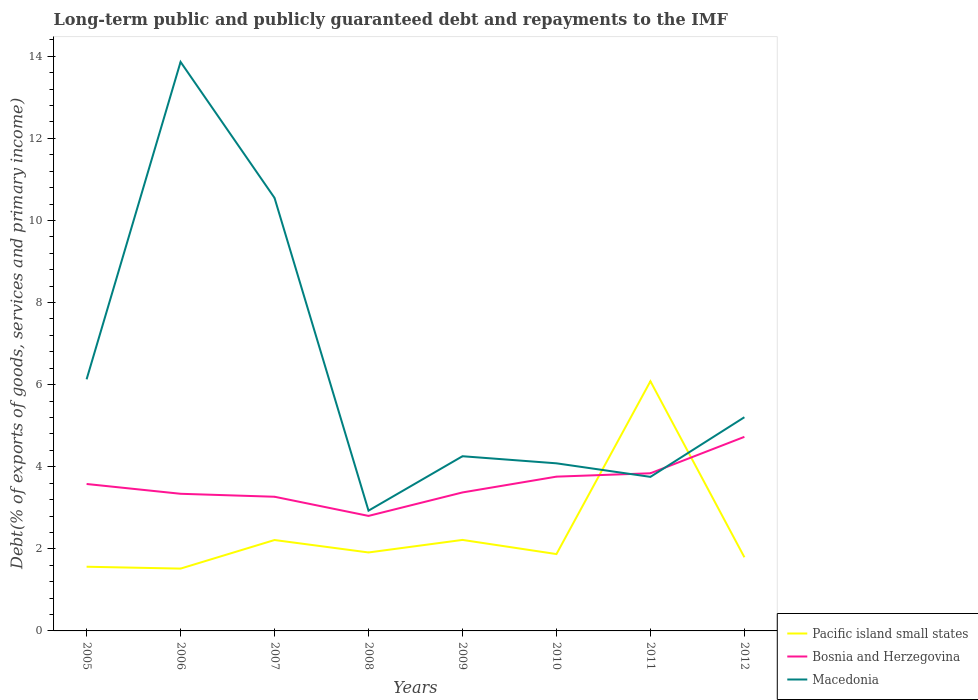Does the line corresponding to Pacific island small states intersect with the line corresponding to Macedonia?
Your answer should be compact. Yes. Is the number of lines equal to the number of legend labels?
Your response must be concise. Yes. Across all years, what is the maximum debt and repayments in Macedonia?
Offer a terse response. 2.93. In which year was the debt and repayments in Bosnia and Herzegovina maximum?
Ensure brevity in your answer.  2008. What is the total debt and repayments in Bosnia and Herzegovina in the graph?
Provide a short and direct response. -1.35. What is the difference between the highest and the second highest debt and repayments in Macedonia?
Your answer should be compact. 10.93. Is the debt and repayments in Bosnia and Herzegovina strictly greater than the debt and repayments in Pacific island small states over the years?
Ensure brevity in your answer.  No. How many lines are there?
Provide a short and direct response. 3. How many years are there in the graph?
Make the answer very short. 8. What is the difference between two consecutive major ticks on the Y-axis?
Offer a very short reply. 2. Does the graph contain any zero values?
Your response must be concise. No. How are the legend labels stacked?
Your answer should be compact. Vertical. What is the title of the graph?
Make the answer very short. Long-term public and publicly guaranteed debt and repayments to the IMF. What is the label or title of the X-axis?
Keep it short and to the point. Years. What is the label or title of the Y-axis?
Offer a very short reply. Debt(% of exports of goods, services and primary income). What is the Debt(% of exports of goods, services and primary income) of Pacific island small states in 2005?
Give a very brief answer. 1.56. What is the Debt(% of exports of goods, services and primary income) of Bosnia and Herzegovina in 2005?
Make the answer very short. 3.58. What is the Debt(% of exports of goods, services and primary income) of Macedonia in 2005?
Your answer should be compact. 6.13. What is the Debt(% of exports of goods, services and primary income) of Pacific island small states in 2006?
Ensure brevity in your answer.  1.52. What is the Debt(% of exports of goods, services and primary income) in Bosnia and Herzegovina in 2006?
Provide a succinct answer. 3.34. What is the Debt(% of exports of goods, services and primary income) in Macedonia in 2006?
Provide a succinct answer. 13.86. What is the Debt(% of exports of goods, services and primary income) of Pacific island small states in 2007?
Ensure brevity in your answer.  2.21. What is the Debt(% of exports of goods, services and primary income) in Bosnia and Herzegovina in 2007?
Make the answer very short. 3.27. What is the Debt(% of exports of goods, services and primary income) in Macedonia in 2007?
Provide a succinct answer. 10.55. What is the Debt(% of exports of goods, services and primary income) of Pacific island small states in 2008?
Give a very brief answer. 1.91. What is the Debt(% of exports of goods, services and primary income) of Bosnia and Herzegovina in 2008?
Offer a terse response. 2.8. What is the Debt(% of exports of goods, services and primary income) in Macedonia in 2008?
Your answer should be compact. 2.93. What is the Debt(% of exports of goods, services and primary income) of Pacific island small states in 2009?
Ensure brevity in your answer.  2.22. What is the Debt(% of exports of goods, services and primary income) of Bosnia and Herzegovina in 2009?
Offer a very short reply. 3.37. What is the Debt(% of exports of goods, services and primary income) of Macedonia in 2009?
Offer a terse response. 4.26. What is the Debt(% of exports of goods, services and primary income) of Pacific island small states in 2010?
Offer a very short reply. 1.87. What is the Debt(% of exports of goods, services and primary income) of Bosnia and Herzegovina in 2010?
Offer a terse response. 3.76. What is the Debt(% of exports of goods, services and primary income) in Macedonia in 2010?
Your response must be concise. 4.08. What is the Debt(% of exports of goods, services and primary income) of Pacific island small states in 2011?
Offer a very short reply. 6.08. What is the Debt(% of exports of goods, services and primary income) of Bosnia and Herzegovina in 2011?
Your response must be concise. 3.84. What is the Debt(% of exports of goods, services and primary income) of Macedonia in 2011?
Provide a short and direct response. 3.75. What is the Debt(% of exports of goods, services and primary income) in Pacific island small states in 2012?
Your answer should be compact. 1.79. What is the Debt(% of exports of goods, services and primary income) of Bosnia and Herzegovina in 2012?
Provide a succinct answer. 4.73. What is the Debt(% of exports of goods, services and primary income) in Macedonia in 2012?
Make the answer very short. 5.21. Across all years, what is the maximum Debt(% of exports of goods, services and primary income) in Pacific island small states?
Provide a short and direct response. 6.08. Across all years, what is the maximum Debt(% of exports of goods, services and primary income) in Bosnia and Herzegovina?
Give a very brief answer. 4.73. Across all years, what is the maximum Debt(% of exports of goods, services and primary income) of Macedonia?
Give a very brief answer. 13.86. Across all years, what is the minimum Debt(% of exports of goods, services and primary income) in Pacific island small states?
Your answer should be compact. 1.52. Across all years, what is the minimum Debt(% of exports of goods, services and primary income) of Bosnia and Herzegovina?
Offer a terse response. 2.8. Across all years, what is the minimum Debt(% of exports of goods, services and primary income) of Macedonia?
Ensure brevity in your answer.  2.93. What is the total Debt(% of exports of goods, services and primary income) in Pacific island small states in the graph?
Make the answer very short. 19.18. What is the total Debt(% of exports of goods, services and primary income) of Bosnia and Herzegovina in the graph?
Give a very brief answer. 28.7. What is the total Debt(% of exports of goods, services and primary income) in Macedonia in the graph?
Your answer should be very brief. 50.77. What is the difference between the Debt(% of exports of goods, services and primary income) of Pacific island small states in 2005 and that in 2006?
Provide a short and direct response. 0.05. What is the difference between the Debt(% of exports of goods, services and primary income) of Bosnia and Herzegovina in 2005 and that in 2006?
Your answer should be very brief. 0.24. What is the difference between the Debt(% of exports of goods, services and primary income) in Macedonia in 2005 and that in 2006?
Give a very brief answer. -7.73. What is the difference between the Debt(% of exports of goods, services and primary income) in Pacific island small states in 2005 and that in 2007?
Keep it short and to the point. -0.65. What is the difference between the Debt(% of exports of goods, services and primary income) in Bosnia and Herzegovina in 2005 and that in 2007?
Your answer should be compact. 0.31. What is the difference between the Debt(% of exports of goods, services and primary income) in Macedonia in 2005 and that in 2007?
Keep it short and to the point. -4.42. What is the difference between the Debt(% of exports of goods, services and primary income) in Pacific island small states in 2005 and that in 2008?
Provide a succinct answer. -0.35. What is the difference between the Debt(% of exports of goods, services and primary income) in Pacific island small states in 2005 and that in 2009?
Give a very brief answer. -0.65. What is the difference between the Debt(% of exports of goods, services and primary income) in Bosnia and Herzegovina in 2005 and that in 2009?
Keep it short and to the point. 0.21. What is the difference between the Debt(% of exports of goods, services and primary income) in Macedonia in 2005 and that in 2009?
Your response must be concise. 1.87. What is the difference between the Debt(% of exports of goods, services and primary income) in Pacific island small states in 2005 and that in 2010?
Offer a very short reply. -0.31. What is the difference between the Debt(% of exports of goods, services and primary income) in Bosnia and Herzegovina in 2005 and that in 2010?
Offer a terse response. -0.18. What is the difference between the Debt(% of exports of goods, services and primary income) in Macedonia in 2005 and that in 2010?
Ensure brevity in your answer.  2.05. What is the difference between the Debt(% of exports of goods, services and primary income) of Pacific island small states in 2005 and that in 2011?
Provide a succinct answer. -4.52. What is the difference between the Debt(% of exports of goods, services and primary income) in Bosnia and Herzegovina in 2005 and that in 2011?
Keep it short and to the point. -0.26. What is the difference between the Debt(% of exports of goods, services and primary income) of Macedonia in 2005 and that in 2011?
Provide a succinct answer. 2.38. What is the difference between the Debt(% of exports of goods, services and primary income) in Pacific island small states in 2005 and that in 2012?
Make the answer very short. -0.23. What is the difference between the Debt(% of exports of goods, services and primary income) in Bosnia and Herzegovina in 2005 and that in 2012?
Make the answer very short. -1.15. What is the difference between the Debt(% of exports of goods, services and primary income) in Macedonia in 2005 and that in 2012?
Keep it short and to the point. 0.92. What is the difference between the Debt(% of exports of goods, services and primary income) in Pacific island small states in 2006 and that in 2007?
Your answer should be compact. -0.7. What is the difference between the Debt(% of exports of goods, services and primary income) of Bosnia and Herzegovina in 2006 and that in 2007?
Provide a succinct answer. 0.07. What is the difference between the Debt(% of exports of goods, services and primary income) of Macedonia in 2006 and that in 2007?
Offer a very short reply. 3.31. What is the difference between the Debt(% of exports of goods, services and primary income) in Pacific island small states in 2006 and that in 2008?
Your response must be concise. -0.39. What is the difference between the Debt(% of exports of goods, services and primary income) in Bosnia and Herzegovina in 2006 and that in 2008?
Your response must be concise. 0.54. What is the difference between the Debt(% of exports of goods, services and primary income) in Macedonia in 2006 and that in 2008?
Give a very brief answer. 10.93. What is the difference between the Debt(% of exports of goods, services and primary income) in Pacific island small states in 2006 and that in 2009?
Offer a very short reply. -0.7. What is the difference between the Debt(% of exports of goods, services and primary income) of Bosnia and Herzegovina in 2006 and that in 2009?
Keep it short and to the point. -0.03. What is the difference between the Debt(% of exports of goods, services and primary income) in Macedonia in 2006 and that in 2009?
Provide a succinct answer. 9.61. What is the difference between the Debt(% of exports of goods, services and primary income) of Pacific island small states in 2006 and that in 2010?
Your answer should be very brief. -0.35. What is the difference between the Debt(% of exports of goods, services and primary income) of Bosnia and Herzegovina in 2006 and that in 2010?
Provide a short and direct response. -0.42. What is the difference between the Debt(% of exports of goods, services and primary income) in Macedonia in 2006 and that in 2010?
Provide a succinct answer. 9.78. What is the difference between the Debt(% of exports of goods, services and primary income) in Pacific island small states in 2006 and that in 2011?
Offer a terse response. -4.57. What is the difference between the Debt(% of exports of goods, services and primary income) in Bosnia and Herzegovina in 2006 and that in 2011?
Your answer should be very brief. -0.5. What is the difference between the Debt(% of exports of goods, services and primary income) in Macedonia in 2006 and that in 2011?
Offer a terse response. 10.11. What is the difference between the Debt(% of exports of goods, services and primary income) of Pacific island small states in 2006 and that in 2012?
Offer a very short reply. -0.28. What is the difference between the Debt(% of exports of goods, services and primary income) in Bosnia and Herzegovina in 2006 and that in 2012?
Your response must be concise. -1.39. What is the difference between the Debt(% of exports of goods, services and primary income) of Macedonia in 2006 and that in 2012?
Keep it short and to the point. 8.66. What is the difference between the Debt(% of exports of goods, services and primary income) of Pacific island small states in 2007 and that in 2008?
Keep it short and to the point. 0.3. What is the difference between the Debt(% of exports of goods, services and primary income) of Bosnia and Herzegovina in 2007 and that in 2008?
Your answer should be compact. 0.47. What is the difference between the Debt(% of exports of goods, services and primary income) of Macedonia in 2007 and that in 2008?
Your response must be concise. 7.62. What is the difference between the Debt(% of exports of goods, services and primary income) in Pacific island small states in 2007 and that in 2009?
Offer a very short reply. -0. What is the difference between the Debt(% of exports of goods, services and primary income) in Bosnia and Herzegovina in 2007 and that in 2009?
Ensure brevity in your answer.  -0.1. What is the difference between the Debt(% of exports of goods, services and primary income) in Macedonia in 2007 and that in 2009?
Your answer should be compact. 6.29. What is the difference between the Debt(% of exports of goods, services and primary income) of Pacific island small states in 2007 and that in 2010?
Offer a very short reply. 0.34. What is the difference between the Debt(% of exports of goods, services and primary income) in Bosnia and Herzegovina in 2007 and that in 2010?
Provide a short and direct response. -0.49. What is the difference between the Debt(% of exports of goods, services and primary income) of Macedonia in 2007 and that in 2010?
Offer a terse response. 6.47. What is the difference between the Debt(% of exports of goods, services and primary income) in Pacific island small states in 2007 and that in 2011?
Offer a very short reply. -3.87. What is the difference between the Debt(% of exports of goods, services and primary income) in Bosnia and Herzegovina in 2007 and that in 2011?
Offer a terse response. -0.57. What is the difference between the Debt(% of exports of goods, services and primary income) in Macedonia in 2007 and that in 2011?
Keep it short and to the point. 6.8. What is the difference between the Debt(% of exports of goods, services and primary income) in Pacific island small states in 2007 and that in 2012?
Provide a succinct answer. 0.42. What is the difference between the Debt(% of exports of goods, services and primary income) of Bosnia and Herzegovina in 2007 and that in 2012?
Your answer should be compact. -1.46. What is the difference between the Debt(% of exports of goods, services and primary income) of Macedonia in 2007 and that in 2012?
Offer a very short reply. 5.34. What is the difference between the Debt(% of exports of goods, services and primary income) in Pacific island small states in 2008 and that in 2009?
Your answer should be compact. -0.31. What is the difference between the Debt(% of exports of goods, services and primary income) of Bosnia and Herzegovina in 2008 and that in 2009?
Ensure brevity in your answer.  -0.57. What is the difference between the Debt(% of exports of goods, services and primary income) in Macedonia in 2008 and that in 2009?
Offer a very short reply. -1.33. What is the difference between the Debt(% of exports of goods, services and primary income) in Pacific island small states in 2008 and that in 2010?
Keep it short and to the point. 0.04. What is the difference between the Debt(% of exports of goods, services and primary income) in Bosnia and Herzegovina in 2008 and that in 2010?
Offer a terse response. -0.96. What is the difference between the Debt(% of exports of goods, services and primary income) in Macedonia in 2008 and that in 2010?
Your answer should be compact. -1.15. What is the difference between the Debt(% of exports of goods, services and primary income) of Pacific island small states in 2008 and that in 2011?
Ensure brevity in your answer.  -4.17. What is the difference between the Debt(% of exports of goods, services and primary income) of Bosnia and Herzegovina in 2008 and that in 2011?
Ensure brevity in your answer.  -1.04. What is the difference between the Debt(% of exports of goods, services and primary income) in Macedonia in 2008 and that in 2011?
Keep it short and to the point. -0.82. What is the difference between the Debt(% of exports of goods, services and primary income) of Pacific island small states in 2008 and that in 2012?
Offer a very short reply. 0.12. What is the difference between the Debt(% of exports of goods, services and primary income) of Bosnia and Herzegovina in 2008 and that in 2012?
Give a very brief answer. -1.93. What is the difference between the Debt(% of exports of goods, services and primary income) in Macedonia in 2008 and that in 2012?
Keep it short and to the point. -2.28. What is the difference between the Debt(% of exports of goods, services and primary income) of Pacific island small states in 2009 and that in 2010?
Ensure brevity in your answer.  0.34. What is the difference between the Debt(% of exports of goods, services and primary income) in Bosnia and Herzegovina in 2009 and that in 2010?
Offer a very short reply. -0.38. What is the difference between the Debt(% of exports of goods, services and primary income) in Macedonia in 2009 and that in 2010?
Offer a terse response. 0.17. What is the difference between the Debt(% of exports of goods, services and primary income) in Pacific island small states in 2009 and that in 2011?
Your answer should be compact. -3.87. What is the difference between the Debt(% of exports of goods, services and primary income) of Bosnia and Herzegovina in 2009 and that in 2011?
Give a very brief answer. -0.47. What is the difference between the Debt(% of exports of goods, services and primary income) of Macedonia in 2009 and that in 2011?
Offer a terse response. 0.5. What is the difference between the Debt(% of exports of goods, services and primary income) of Pacific island small states in 2009 and that in 2012?
Ensure brevity in your answer.  0.42. What is the difference between the Debt(% of exports of goods, services and primary income) in Bosnia and Herzegovina in 2009 and that in 2012?
Make the answer very short. -1.35. What is the difference between the Debt(% of exports of goods, services and primary income) in Macedonia in 2009 and that in 2012?
Offer a very short reply. -0.95. What is the difference between the Debt(% of exports of goods, services and primary income) of Pacific island small states in 2010 and that in 2011?
Your response must be concise. -4.21. What is the difference between the Debt(% of exports of goods, services and primary income) of Bosnia and Herzegovina in 2010 and that in 2011?
Give a very brief answer. -0.08. What is the difference between the Debt(% of exports of goods, services and primary income) of Macedonia in 2010 and that in 2011?
Your response must be concise. 0.33. What is the difference between the Debt(% of exports of goods, services and primary income) in Pacific island small states in 2010 and that in 2012?
Offer a very short reply. 0.08. What is the difference between the Debt(% of exports of goods, services and primary income) in Bosnia and Herzegovina in 2010 and that in 2012?
Your answer should be very brief. -0.97. What is the difference between the Debt(% of exports of goods, services and primary income) of Macedonia in 2010 and that in 2012?
Give a very brief answer. -1.12. What is the difference between the Debt(% of exports of goods, services and primary income) in Pacific island small states in 2011 and that in 2012?
Give a very brief answer. 4.29. What is the difference between the Debt(% of exports of goods, services and primary income) in Bosnia and Herzegovina in 2011 and that in 2012?
Provide a succinct answer. -0.89. What is the difference between the Debt(% of exports of goods, services and primary income) of Macedonia in 2011 and that in 2012?
Your answer should be very brief. -1.45. What is the difference between the Debt(% of exports of goods, services and primary income) in Pacific island small states in 2005 and the Debt(% of exports of goods, services and primary income) in Bosnia and Herzegovina in 2006?
Provide a short and direct response. -1.78. What is the difference between the Debt(% of exports of goods, services and primary income) in Pacific island small states in 2005 and the Debt(% of exports of goods, services and primary income) in Macedonia in 2006?
Ensure brevity in your answer.  -12.3. What is the difference between the Debt(% of exports of goods, services and primary income) in Bosnia and Herzegovina in 2005 and the Debt(% of exports of goods, services and primary income) in Macedonia in 2006?
Your answer should be compact. -10.28. What is the difference between the Debt(% of exports of goods, services and primary income) in Pacific island small states in 2005 and the Debt(% of exports of goods, services and primary income) in Bosnia and Herzegovina in 2007?
Ensure brevity in your answer.  -1.71. What is the difference between the Debt(% of exports of goods, services and primary income) of Pacific island small states in 2005 and the Debt(% of exports of goods, services and primary income) of Macedonia in 2007?
Your response must be concise. -8.99. What is the difference between the Debt(% of exports of goods, services and primary income) of Bosnia and Herzegovina in 2005 and the Debt(% of exports of goods, services and primary income) of Macedonia in 2007?
Give a very brief answer. -6.97. What is the difference between the Debt(% of exports of goods, services and primary income) in Pacific island small states in 2005 and the Debt(% of exports of goods, services and primary income) in Bosnia and Herzegovina in 2008?
Your answer should be compact. -1.24. What is the difference between the Debt(% of exports of goods, services and primary income) in Pacific island small states in 2005 and the Debt(% of exports of goods, services and primary income) in Macedonia in 2008?
Make the answer very short. -1.37. What is the difference between the Debt(% of exports of goods, services and primary income) in Bosnia and Herzegovina in 2005 and the Debt(% of exports of goods, services and primary income) in Macedonia in 2008?
Give a very brief answer. 0.65. What is the difference between the Debt(% of exports of goods, services and primary income) in Pacific island small states in 2005 and the Debt(% of exports of goods, services and primary income) in Bosnia and Herzegovina in 2009?
Provide a succinct answer. -1.81. What is the difference between the Debt(% of exports of goods, services and primary income) of Pacific island small states in 2005 and the Debt(% of exports of goods, services and primary income) of Macedonia in 2009?
Provide a succinct answer. -2.69. What is the difference between the Debt(% of exports of goods, services and primary income) of Bosnia and Herzegovina in 2005 and the Debt(% of exports of goods, services and primary income) of Macedonia in 2009?
Provide a succinct answer. -0.68. What is the difference between the Debt(% of exports of goods, services and primary income) in Pacific island small states in 2005 and the Debt(% of exports of goods, services and primary income) in Bosnia and Herzegovina in 2010?
Offer a very short reply. -2.2. What is the difference between the Debt(% of exports of goods, services and primary income) of Pacific island small states in 2005 and the Debt(% of exports of goods, services and primary income) of Macedonia in 2010?
Your answer should be compact. -2.52. What is the difference between the Debt(% of exports of goods, services and primary income) in Bosnia and Herzegovina in 2005 and the Debt(% of exports of goods, services and primary income) in Macedonia in 2010?
Your answer should be compact. -0.5. What is the difference between the Debt(% of exports of goods, services and primary income) in Pacific island small states in 2005 and the Debt(% of exports of goods, services and primary income) in Bosnia and Herzegovina in 2011?
Provide a short and direct response. -2.28. What is the difference between the Debt(% of exports of goods, services and primary income) in Pacific island small states in 2005 and the Debt(% of exports of goods, services and primary income) in Macedonia in 2011?
Make the answer very short. -2.19. What is the difference between the Debt(% of exports of goods, services and primary income) of Bosnia and Herzegovina in 2005 and the Debt(% of exports of goods, services and primary income) of Macedonia in 2011?
Your response must be concise. -0.17. What is the difference between the Debt(% of exports of goods, services and primary income) of Pacific island small states in 2005 and the Debt(% of exports of goods, services and primary income) of Bosnia and Herzegovina in 2012?
Your answer should be compact. -3.16. What is the difference between the Debt(% of exports of goods, services and primary income) of Pacific island small states in 2005 and the Debt(% of exports of goods, services and primary income) of Macedonia in 2012?
Make the answer very short. -3.64. What is the difference between the Debt(% of exports of goods, services and primary income) of Bosnia and Herzegovina in 2005 and the Debt(% of exports of goods, services and primary income) of Macedonia in 2012?
Your answer should be very brief. -1.63. What is the difference between the Debt(% of exports of goods, services and primary income) of Pacific island small states in 2006 and the Debt(% of exports of goods, services and primary income) of Bosnia and Herzegovina in 2007?
Your answer should be very brief. -1.75. What is the difference between the Debt(% of exports of goods, services and primary income) of Pacific island small states in 2006 and the Debt(% of exports of goods, services and primary income) of Macedonia in 2007?
Make the answer very short. -9.03. What is the difference between the Debt(% of exports of goods, services and primary income) in Bosnia and Herzegovina in 2006 and the Debt(% of exports of goods, services and primary income) in Macedonia in 2007?
Your response must be concise. -7.21. What is the difference between the Debt(% of exports of goods, services and primary income) of Pacific island small states in 2006 and the Debt(% of exports of goods, services and primary income) of Bosnia and Herzegovina in 2008?
Your response must be concise. -1.28. What is the difference between the Debt(% of exports of goods, services and primary income) of Pacific island small states in 2006 and the Debt(% of exports of goods, services and primary income) of Macedonia in 2008?
Make the answer very short. -1.41. What is the difference between the Debt(% of exports of goods, services and primary income) of Bosnia and Herzegovina in 2006 and the Debt(% of exports of goods, services and primary income) of Macedonia in 2008?
Your response must be concise. 0.41. What is the difference between the Debt(% of exports of goods, services and primary income) of Pacific island small states in 2006 and the Debt(% of exports of goods, services and primary income) of Bosnia and Herzegovina in 2009?
Provide a short and direct response. -1.86. What is the difference between the Debt(% of exports of goods, services and primary income) of Pacific island small states in 2006 and the Debt(% of exports of goods, services and primary income) of Macedonia in 2009?
Your answer should be very brief. -2.74. What is the difference between the Debt(% of exports of goods, services and primary income) in Bosnia and Herzegovina in 2006 and the Debt(% of exports of goods, services and primary income) in Macedonia in 2009?
Offer a very short reply. -0.92. What is the difference between the Debt(% of exports of goods, services and primary income) in Pacific island small states in 2006 and the Debt(% of exports of goods, services and primary income) in Bosnia and Herzegovina in 2010?
Provide a succinct answer. -2.24. What is the difference between the Debt(% of exports of goods, services and primary income) in Pacific island small states in 2006 and the Debt(% of exports of goods, services and primary income) in Macedonia in 2010?
Your answer should be very brief. -2.57. What is the difference between the Debt(% of exports of goods, services and primary income) in Bosnia and Herzegovina in 2006 and the Debt(% of exports of goods, services and primary income) in Macedonia in 2010?
Make the answer very short. -0.74. What is the difference between the Debt(% of exports of goods, services and primary income) in Pacific island small states in 2006 and the Debt(% of exports of goods, services and primary income) in Bosnia and Herzegovina in 2011?
Provide a succinct answer. -2.32. What is the difference between the Debt(% of exports of goods, services and primary income) of Pacific island small states in 2006 and the Debt(% of exports of goods, services and primary income) of Macedonia in 2011?
Provide a succinct answer. -2.23. What is the difference between the Debt(% of exports of goods, services and primary income) in Bosnia and Herzegovina in 2006 and the Debt(% of exports of goods, services and primary income) in Macedonia in 2011?
Your answer should be very brief. -0.41. What is the difference between the Debt(% of exports of goods, services and primary income) in Pacific island small states in 2006 and the Debt(% of exports of goods, services and primary income) in Bosnia and Herzegovina in 2012?
Provide a succinct answer. -3.21. What is the difference between the Debt(% of exports of goods, services and primary income) in Pacific island small states in 2006 and the Debt(% of exports of goods, services and primary income) in Macedonia in 2012?
Your answer should be very brief. -3.69. What is the difference between the Debt(% of exports of goods, services and primary income) of Bosnia and Herzegovina in 2006 and the Debt(% of exports of goods, services and primary income) of Macedonia in 2012?
Provide a short and direct response. -1.87. What is the difference between the Debt(% of exports of goods, services and primary income) in Pacific island small states in 2007 and the Debt(% of exports of goods, services and primary income) in Bosnia and Herzegovina in 2008?
Offer a terse response. -0.59. What is the difference between the Debt(% of exports of goods, services and primary income) in Pacific island small states in 2007 and the Debt(% of exports of goods, services and primary income) in Macedonia in 2008?
Offer a terse response. -0.72. What is the difference between the Debt(% of exports of goods, services and primary income) in Bosnia and Herzegovina in 2007 and the Debt(% of exports of goods, services and primary income) in Macedonia in 2008?
Provide a succinct answer. 0.34. What is the difference between the Debt(% of exports of goods, services and primary income) in Pacific island small states in 2007 and the Debt(% of exports of goods, services and primary income) in Bosnia and Herzegovina in 2009?
Ensure brevity in your answer.  -1.16. What is the difference between the Debt(% of exports of goods, services and primary income) in Pacific island small states in 2007 and the Debt(% of exports of goods, services and primary income) in Macedonia in 2009?
Make the answer very short. -2.04. What is the difference between the Debt(% of exports of goods, services and primary income) of Bosnia and Herzegovina in 2007 and the Debt(% of exports of goods, services and primary income) of Macedonia in 2009?
Your answer should be compact. -0.99. What is the difference between the Debt(% of exports of goods, services and primary income) in Pacific island small states in 2007 and the Debt(% of exports of goods, services and primary income) in Bosnia and Herzegovina in 2010?
Provide a short and direct response. -1.54. What is the difference between the Debt(% of exports of goods, services and primary income) of Pacific island small states in 2007 and the Debt(% of exports of goods, services and primary income) of Macedonia in 2010?
Give a very brief answer. -1.87. What is the difference between the Debt(% of exports of goods, services and primary income) of Bosnia and Herzegovina in 2007 and the Debt(% of exports of goods, services and primary income) of Macedonia in 2010?
Your answer should be compact. -0.81. What is the difference between the Debt(% of exports of goods, services and primary income) of Pacific island small states in 2007 and the Debt(% of exports of goods, services and primary income) of Bosnia and Herzegovina in 2011?
Provide a succinct answer. -1.63. What is the difference between the Debt(% of exports of goods, services and primary income) of Pacific island small states in 2007 and the Debt(% of exports of goods, services and primary income) of Macedonia in 2011?
Provide a short and direct response. -1.54. What is the difference between the Debt(% of exports of goods, services and primary income) in Bosnia and Herzegovina in 2007 and the Debt(% of exports of goods, services and primary income) in Macedonia in 2011?
Your answer should be very brief. -0.48. What is the difference between the Debt(% of exports of goods, services and primary income) in Pacific island small states in 2007 and the Debt(% of exports of goods, services and primary income) in Bosnia and Herzegovina in 2012?
Provide a short and direct response. -2.51. What is the difference between the Debt(% of exports of goods, services and primary income) of Pacific island small states in 2007 and the Debt(% of exports of goods, services and primary income) of Macedonia in 2012?
Make the answer very short. -2.99. What is the difference between the Debt(% of exports of goods, services and primary income) in Bosnia and Herzegovina in 2007 and the Debt(% of exports of goods, services and primary income) in Macedonia in 2012?
Offer a very short reply. -1.94. What is the difference between the Debt(% of exports of goods, services and primary income) in Pacific island small states in 2008 and the Debt(% of exports of goods, services and primary income) in Bosnia and Herzegovina in 2009?
Give a very brief answer. -1.46. What is the difference between the Debt(% of exports of goods, services and primary income) in Pacific island small states in 2008 and the Debt(% of exports of goods, services and primary income) in Macedonia in 2009?
Your answer should be very brief. -2.34. What is the difference between the Debt(% of exports of goods, services and primary income) in Bosnia and Herzegovina in 2008 and the Debt(% of exports of goods, services and primary income) in Macedonia in 2009?
Keep it short and to the point. -1.45. What is the difference between the Debt(% of exports of goods, services and primary income) in Pacific island small states in 2008 and the Debt(% of exports of goods, services and primary income) in Bosnia and Herzegovina in 2010?
Offer a very short reply. -1.85. What is the difference between the Debt(% of exports of goods, services and primary income) in Pacific island small states in 2008 and the Debt(% of exports of goods, services and primary income) in Macedonia in 2010?
Keep it short and to the point. -2.17. What is the difference between the Debt(% of exports of goods, services and primary income) in Bosnia and Herzegovina in 2008 and the Debt(% of exports of goods, services and primary income) in Macedonia in 2010?
Provide a short and direct response. -1.28. What is the difference between the Debt(% of exports of goods, services and primary income) of Pacific island small states in 2008 and the Debt(% of exports of goods, services and primary income) of Bosnia and Herzegovina in 2011?
Offer a terse response. -1.93. What is the difference between the Debt(% of exports of goods, services and primary income) of Pacific island small states in 2008 and the Debt(% of exports of goods, services and primary income) of Macedonia in 2011?
Give a very brief answer. -1.84. What is the difference between the Debt(% of exports of goods, services and primary income) in Bosnia and Herzegovina in 2008 and the Debt(% of exports of goods, services and primary income) in Macedonia in 2011?
Keep it short and to the point. -0.95. What is the difference between the Debt(% of exports of goods, services and primary income) of Pacific island small states in 2008 and the Debt(% of exports of goods, services and primary income) of Bosnia and Herzegovina in 2012?
Ensure brevity in your answer.  -2.82. What is the difference between the Debt(% of exports of goods, services and primary income) in Pacific island small states in 2008 and the Debt(% of exports of goods, services and primary income) in Macedonia in 2012?
Keep it short and to the point. -3.3. What is the difference between the Debt(% of exports of goods, services and primary income) of Bosnia and Herzegovina in 2008 and the Debt(% of exports of goods, services and primary income) of Macedonia in 2012?
Your answer should be compact. -2.4. What is the difference between the Debt(% of exports of goods, services and primary income) in Pacific island small states in 2009 and the Debt(% of exports of goods, services and primary income) in Bosnia and Herzegovina in 2010?
Give a very brief answer. -1.54. What is the difference between the Debt(% of exports of goods, services and primary income) in Pacific island small states in 2009 and the Debt(% of exports of goods, services and primary income) in Macedonia in 2010?
Offer a very short reply. -1.87. What is the difference between the Debt(% of exports of goods, services and primary income) in Bosnia and Herzegovina in 2009 and the Debt(% of exports of goods, services and primary income) in Macedonia in 2010?
Offer a terse response. -0.71. What is the difference between the Debt(% of exports of goods, services and primary income) of Pacific island small states in 2009 and the Debt(% of exports of goods, services and primary income) of Bosnia and Herzegovina in 2011?
Offer a terse response. -1.62. What is the difference between the Debt(% of exports of goods, services and primary income) in Pacific island small states in 2009 and the Debt(% of exports of goods, services and primary income) in Macedonia in 2011?
Make the answer very short. -1.54. What is the difference between the Debt(% of exports of goods, services and primary income) of Bosnia and Herzegovina in 2009 and the Debt(% of exports of goods, services and primary income) of Macedonia in 2011?
Your response must be concise. -0.38. What is the difference between the Debt(% of exports of goods, services and primary income) in Pacific island small states in 2009 and the Debt(% of exports of goods, services and primary income) in Bosnia and Herzegovina in 2012?
Make the answer very short. -2.51. What is the difference between the Debt(% of exports of goods, services and primary income) of Pacific island small states in 2009 and the Debt(% of exports of goods, services and primary income) of Macedonia in 2012?
Make the answer very short. -2.99. What is the difference between the Debt(% of exports of goods, services and primary income) in Bosnia and Herzegovina in 2009 and the Debt(% of exports of goods, services and primary income) in Macedonia in 2012?
Offer a terse response. -1.83. What is the difference between the Debt(% of exports of goods, services and primary income) in Pacific island small states in 2010 and the Debt(% of exports of goods, services and primary income) in Bosnia and Herzegovina in 2011?
Offer a terse response. -1.97. What is the difference between the Debt(% of exports of goods, services and primary income) in Pacific island small states in 2010 and the Debt(% of exports of goods, services and primary income) in Macedonia in 2011?
Your answer should be very brief. -1.88. What is the difference between the Debt(% of exports of goods, services and primary income) of Bosnia and Herzegovina in 2010 and the Debt(% of exports of goods, services and primary income) of Macedonia in 2011?
Your response must be concise. 0.01. What is the difference between the Debt(% of exports of goods, services and primary income) of Pacific island small states in 2010 and the Debt(% of exports of goods, services and primary income) of Bosnia and Herzegovina in 2012?
Your response must be concise. -2.86. What is the difference between the Debt(% of exports of goods, services and primary income) in Pacific island small states in 2010 and the Debt(% of exports of goods, services and primary income) in Macedonia in 2012?
Keep it short and to the point. -3.33. What is the difference between the Debt(% of exports of goods, services and primary income) of Bosnia and Herzegovina in 2010 and the Debt(% of exports of goods, services and primary income) of Macedonia in 2012?
Provide a succinct answer. -1.45. What is the difference between the Debt(% of exports of goods, services and primary income) in Pacific island small states in 2011 and the Debt(% of exports of goods, services and primary income) in Bosnia and Herzegovina in 2012?
Offer a terse response. 1.36. What is the difference between the Debt(% of exports of goods, services and primary income) of Pacific island small states in 2011 and the Debt(% of exports of goods, services and primary income) of Macedonia in 2012?
Your response must be concise. 0.88. What is the difference between the Debt(% of exports of goods, services and primary income) in Bosnia and Herzegovina in 2011 and the Debt(% of exports of goods, services and primary income) in Macedonia in 2012?
Provide a succinct answer. -1.37. What is the average Debt(% of exports of goods, services and primary income) of Pacific island small states per year?
Make the answer very short. 2.4. What is the average Debt(% of exports of goods, services and primary income) of Bosnia and Herzegovina per year?
Offer a very short reply. 3.59. What is the average Debt(% of exports of goods, services and primary income) of Macedonia per year?
Ensure brevity in your answer.  6.35. In the year 2005, what is the difference between the Debt(% of exports of goods, services and primary income) in Pacific island small states and Debt(% of exports of goods, services and primary income) in Bosnia and Herzegovina?
Offer a very short reply. -2.02. In the year 2005, what is the difference between the Debt(% of exports of goods, services and primary income) of Pacific island small states and Debt(% of exports of goods, services and primary income) of Macedonia?
Your response must be concise. -4.57. In the year 2005, what is the difference between the Debt(% of exports of goods, services and primary income) of Bosnia and Herzegovina and Debt(% of exports of goods, services and primary income) of Macedonia?
Your answer should be compact. -2.55. In the year 2006, what is the difference between the Debt(% of exports of goods, services and primary income) in Pacific island small states and Debt(% of exports of goods, services and primary income) in Bosnia and Herzegovina?
Offer a terse response. -1.82. In the year 2006, what is the difference between the Debt(% of exports of goods, services and primary income) in Pacific island small states and Debt(% of exports of goods, services and primary income) in Macedonia?
Your answer should be compact. -12.35. In the year 2006, what is the difference between the Debt(% of exports of goods, services and primary income) of Bosnia and Herzegovina and Debt(% of exports of goods, services and primary income) of Macedonia?
Keep it short and to the point. -10.52. In the year 2007, what is the difference between the Debt(% of exports of goods, services and primary income) in Pacific island small states and Debt(% of exports of goods, services and primary income) in Bosnia and Herzegovina?
Your response must be concise. -1.05. In the year 2007, what is the difference between the Debt(% of exports of goods, services and primary income) in Pacific island small states and Debt(% of exports of goods, services and primary income) in Macedonia?
Offer a very short reply. -8.34. In the year 2007, what is the difference between the Debt(% of exports of goods, services and primary income) of Bosnia and Herzegovina and Debt(% of exports of goods, services and primary income) of Macedonia?
Give a very brief answer. -7.28. In the year 2008, what is the difference between the Debt(% of exports of goods, services and primary income) of Pacific island small states and Debt(% of exports of goods, services and primary income) of Bosnia and Herzegovina?
Give a very brief answer. -0.89. In the year 2008, what is the difference between the Debt(% of exports of goods, services and primary income) in Pacific island small states and Debt(% of exports of goods, services and primary income) in Macedonia?
Your response must be concise. -1.02. In the year 2008, what is the difference between the Debt(% of exports of goods, services and primary income) of Bosnia and Herzegovina and Debt(% of exports of goods, services and primary income) of Macedonia?
Provide a succinct answer. -0.13. In the year 2009, what is the difference between the Debt(% of exports of goods, services and primary income) in Pacific island small states and Debt(% of exports of goods, services and primary income) in Bosnia and Herzegovina?
Provide a succinct answer. -1.16. In the year 2009, what is the difference between the Debt(% of exports of goods, services and primary income) in Pacific island small states and Debt(% of exports of goods, services and primary income) in Macedonia?
Offer a very short reply. -2.04. In the year 2009, what is the difference between the Debt(% of exports of goods, services and primary income) in Bosnia and Herzegovina and Debt(% of exports of goods, services and primary income) in Macedonia?
Offer a very short reply. -0.88. In the year 2010, what is the difference between the Debt(% of exports of goods, services and primary income) of Pacific island small states and Debt(% of exports of goods, services and primary income) of Bosnia and Herzegovina?
Provide a short and direct response. -1.89. In the year 2010, what is the difference between the Debt(% of exports of goods, services and primary income) in Pacific island small states and Debt(% of exports of goods, services and primary income) in Macedonia?
Offer a very short reply. -2.21. In the year 2010, what is the difference between the Debt(% of exports of goods, services and primary income) in Bosnia and Herzegovina and Debt(% of exports of goods, services and primary income) in Macedonia?
Provide a succinct answer. -0.32. In the year 2011, what is the difference between the Debt(% of exports of goods, services and primary income) in Pacific island small states and Debt(% of exports of goods, services and primary income) in Bosnia and Herzegovina?
Ensure brevity in your answer.  2.24. In the year 2011, what is the difference between the Debt(% of exports of goods, services and primary income) in Pacific island small states and Debt(% of exports of goods, services and primary income) in Macedonia?
Keep it short and to the point. 2.33. In the year 2011, what is the difference between the Debt(% of exports of goods, services and primary income) of Bosnia and Herzegovina and Debt(% of exports of goods, services and primary income) of Macedonia?
Offer a terse response. 0.09. In the year 2012, what is the difference between the Debt(% of exports of goods, services and primary income) in Pacific island small states and Debt(% of exports of goods, services and primary income) in Bosnia and Herzegovina?
Offer a very short reply. -2.93. In the year 2012, what is the difference between the Debt(% of exports of goods, services and primary income) in Pacific island small states and Debt(% of exports of goods, services and primary income) in Macedonia?
Ensure brevity in your answer.  -3.41. In the year 2012, what is the difference between the Debt(% of exports of goods, services and primary income) in Bosnia and Herzegovina and Debt(% of exports of goods, services and primary income) in Macedonia?
Keep it short and to the point. -0.48. What is the ratio of the Debt(% of exports of goods, services and primary income) in Pacific island small states in 2005 to that in 2006?
Provide a succinct answer. 1.03. What is the ratio of the Debt(% of exports of goods, services and primary income) in Bosnia and Herzegovina in 2005 to that in 2006?
Give a very brief answer. 1.07. What is the ratio of the Debt(% of exports of goods, services and primary income) of Macedonia in 2005 to that in 2006?
Your response must be concise. 0.44. What is the ratio of the Debt(% of exports of goods, services and primary income) of Pacific island small states in 2005 to that in 2007?
Provide a short and direct response. 0.71. What is the ratio of the Debt(% of exports of goods, services and primary income) in Bosnia and Herzegovina in 2005 to that in 2007?
Your answer should be very brief. 1.1. What is the ratio of the Debt(% of exports of goods, services and primary income) in Macedonia in 2005 to that in 2007?
Your response must be concise. 0.58. What is the ratio of the Debt(% of exports of goods, services and primary income) of Pacific island small states in 2005 to that in 2008?
Keep it short and to the point. 0.82. What is the ratio of the Debt(% of exports of goods, services and primary income) of Bosnia and Herzegovina in 2005 to that in 2008?
Your answer should be very brief. 1.28. What is the ratio of the Debt(% of exports of goods, services and primary income) in Macedonia in 2005 to that in 2008?
Give a very brief answer. 2.09. What is the ratio of the Debt(% of exports of goods, services and primary income) in Pacific island small states in 2005 to that in 2009?
Your answer should be compact. 0.71. What is the ratio of the Debt(% of exports of goods, services and primary income) of Bosnia and Herzegovina in 2005 to that in 2009?
Ensure brevity in your answer.  1.06. What is the ratio of the Debt(% of exports of goods, services and primary income) of Macedonia in 2005 to that in 2009?
Your response must be concise. 1.44. What is the ratio of the Debt(% of exports of goods, services and primary income) of Pacific island small states in 2005 to that in 2010?
Your response must be concise. 0.84. What is the ratio of the Debt(% of exports of goods, services and primary income) in Macedonia in 2005 to that in 2010?
Make the answer very short. 1.5. What is the ratio of the Debt(% of exports of goods, services and primary income) of Pacific island small states in 2005 to that in 2011?
Offer a very short reply. 0.26. What is the ratio of the Debt(% of exports of goods, services and primary income) of Bosnia and Herzegovina in 2005 to that in 2011?
Your answer should be very brief. 0.93. What is the ratio of the Debt(% of exports of goods, services and primary income) of Macedonia in 2005 to that in 2011?
Make the answer very short. 1.63. What is the ratio of the Debt(% of exports of goods, services and primary income) in Pacific island small states in 2005 to that in 2012?
Your answer should be very brief. 0.87. What is the ratio of the Debt(% of exports of goods, services and primary income) in Bosnia and Herzegovina in 2005 to that in 2012?
Give a very brief answer. 0.76. What is the ratio of the Debt(% of exports of goods, services and primary income) in Macedonia in 2005 to that in 2012?
Keep it short and to the point. 1.18. What is the ratio of the Debt(% of exports of goods, services and primary income) in Pacific island small states in 2006 to that in 2007?
Offer a very short reply. 0.69. What is the ratio of the Debt(% of exports of goods, services and primary income) of Bosnia and Herzegovina in 2006 to that in 2007?
Keep it short and to the point. 1.02. What is the ratio of the Debt(% of exports of goods, services and primary income) of Macedonia in 2006 to that in 2007?
Your answer should be very brief. 1.31. What is the ratio of the Debt(% of exports of goods, services and primary income) of Pacific island small states in 2006 to that in 2008?
Make the answer very short. 0.79. What is the ratio of the Debt(% of exports of goods, services and primary income) in Bosnia and Herzegovina in 2006 to that in 2008?
Offer a very short reply. 1.19. What is the ratio of the Debt(% of exports of goods, services and primary income) of Macedonia in 2006 to that in 2008?
Offer a very short reply. 4.73. What is the ratio of the Debt(% of exports of goods, services and primary income) of Pacific island small states in 2006 to that in 2009?
Keep it short and to the point. 0.68. What is the ratio of the Debt(% of exports of goods, services and primary income) of Bosnia and Herzegovina in 2006 to that in 2009?
Make the answer very short. 0.99. What is the ratio of the Debt(% of exports of goods, services and primary income) in Macedonia in 2006 to that in 2009?
Your response must be concise. 3.26. What is the ratio of the Debt(% of exports of goods, services and primary income) of Pacific island small states in 2006 to that in 2010?
Make the answer very short. 0.81. What is the ratio of the Debt(% of exports of goods, services and primary income) in Bosnia and Herzegovina in 2006 to that in 2010?
Your answer should be very brief. 0.89. What is the ratio of the Debt(% of exports of goods, services and primary income) of Macedonia in 2006 to that in 2010?
Offer a terse response. 3.4. What is the ratio of the Debt(% of exports of goods, services and primary income) of Pacific island small states in 2006 to that in 2011?
Provide a succinct answer. 0.25. What is the ratio of the Debt(% of exports of goods, services and primary income) of Bosnia and Herzegovina in 2006 to that in 2011?
Your answer should be compact. 0.87. What is the ratio of the Debt(% of exports of goods, services and primary income) in Macedonia in 2006 to that in 2011?
Keep it short and to the point. 3.69. What is the ratio of the Debt(% of exports of goods, services and primary income) in Pacific island small states in 2006 to that in 2012?
Give a very brief answer. 0.85. What is the ratio of the Debt(% of exports of goods, services and primary income) of Bosnia and Herzegovina in 2006 to that in 2012?
Your answer should be compact. 0.71. What is the ratio of the Debt(% of exports of goods, services and primary income) of Macedonia in 2006 to that in 2012?
Your answer should be very brief. 2.66. What is the ratio of the Debt(% of exports of goods, services and primary income) in Pacific island small states in 2007 to that in 2008?
Your answer should be compact. 1.16. What is the ratio of the Debt(% of exports of goods, services and primary income) in Bosnia and Herzegovina in 2007 to that in 2008?
Offer a very short reply. 1.17. What is the ratio of the Debt(% of exports of goods, services and primary income) in Macedonia in 2007 to that in 2008?
Offer a terse response. 3.6. What is the ratio of the Debt(% of exports of goods, services and primary income) in Bosnia and Herzegovina in 2007 to that in 2009?
Make the answer very short. 0.97. What is the ratio of the Debt(% of exports of goods, services and primary income) of Macedonia in 2007 to that in 2009?
Your answer should be very brief. 2.48. What is the ratio of the Debt(% of exports of goods, services and primary income) in Pacific island small states in 2007 to that in 2010?
Your answer should be very brief. 1.18. What is the ratio of the Debt(% of exports of goods, services and primary income) of Bosnia and Herzegovina in 2007 to that in 2010?
Your answer should be compact. 0.87. What is the ratio of the Debt(% of exports of goods, services and primary income) of Macedonia in 2007 to that in 2010?
Offer a terse response. 2.58. What is the ratio of the Debt(% of exports of goods, services and primary income) in Pacific island small states in 2007 to that in 2011?
Give a very brief answer. 0.36. What is the ratio of the Debt(% of exports of goods, services and primary income) in Bosnia and Herzegovina in 2007 to that in 2011?
Provide a short and direct response. 0.85. What is the ratio of the Debt(% of exports of goods, services and primary income) of Macedonia in 2007 to that in 2011?
Keep it short and to the point. 2.81. What is the ratio of the Debt(% of exports of goods, services and primary income) in Pacific island small states in 2007 to that in 2012?
Your response must be concise. 1.23. What is the ratio of the Debt(% of exports of goods, services and primary income) of Bosnia and Herzegovina in 2007 to that in 2012?
Your answer should be very brief. 0.69. What is the ratio of the Debt(% of exports of goods, services and primary income) of Macedonia in 2007 to that in 2012?
Your answer should be very brief. 2.03. What is the ratio of the Debt(% of exports of goods, services and primary income) in Pacific island small states in 2008 to that in 2009?
Offer a very short reply. 0.86. What is the ratio of the Debt(% of exports of goods, services and primary income) in Bosnia and Herzegovina in 2008 to that in 2009?
Your answer should be compact. 0.83. What is the ratio of the Debt(% of exports of goods, services and primary income) of Macedonia in 2008 to that in 2009?
Give a very brief answer. 0.69. What is the ratio of the Debt(% of exports of goods, services and primary income) in Pacific island small states in 2008 to that in 2010?
Your response must be concise. 1.02. What is the ratio of the Debt(% of exports of goods, services and primary income) in Bosnia and Herzegovina in 2008 to that in 2010?
Keep it short and to the point. 0.75. What is the ratio of the Debt(% of exports of goods, services and primary income) of Macedonia in 2008 to that in 2010?
Your answer should be compact. 0.72. What is the ratio of the Debt(% of exports of goods, services and primary income) in Pacific island small states in 2008 to that in 2011?
Make the answer very short. 0.31. What is the ratio of the Debt(% of exports of goods, services and primary income) of Bosnia and Herzegovina in 2008 to that in 2011?
Your answer should be compact. 0.73. What is the ratio of the Debt(% of exports of goods, services and primary income) in Macedonia in 2008 to that in 2011?
Your answer should be compact. 0.78. What is the ratio of the Debt(% of exports of goods, services and primary income) of Pacific island small states in 2008 to that in 2012?
Offer a terse response. 1.07. What is the ratio of the Debt(% of exports of goods, services and primary income) in Bosnia and Herzegovina in 2008 to that in 2012?
Your response must be concise. 0.59. What is the ratio of the Debt(% of exports of goods, services and primary income) in Macedonia in 2008 to that in 2012?
Give a very brief answer. 0.56. What is the ratio of the Debt(% of exports of goods, services and primary income) of Pacific island small states in 2009 to that in 2010?
Your answer should be compact. 1.18. What is the ratio of the Debt(% of exports of goods, services and primary income) in Bosnia and Herzegovina in 2009 to that in 2010?
Ensure brevity in your answer.  0.9. What is the ratio of the Debt(% of exports of goods, services and primary income) in Macedonia in 2009 to that in 2010?
Give a very brief answer. 1.04. What is the ratio of the Debt(% of exports of goods, services and primary income) in Pacific island small states in 2009 to that in 2011?
Offer a very short reply. 0.36. What is the ratio of the Debt(% of exports of goods, services and primary income) in Bosnia and Herzegovina in 2009 to that in 2011?
Provide a short and direct response. 0.88. What is the ratio of the Debt(% of exports of goods, services and primary income) of Macedonia in 2009 to that in 2011?
Make the answer very short. 1.13. What is the ratio of the Debt(% of exports of goods, services and primary income) of Pacific island small states in 2009 to that in 2012?
Give a very brief answer. 1.24. What is the ratio of the Debt(% of exports of goods, services and primary income) of Bosnia and Herzegovina in 2009 to that in 2012?
Provide a short and direct response. 0.71. What is the ratio of the Debt(% of exports of goods, services and primary income) of Macedonia in 2009 to that in 2012?
Provide a short and direct response. 0.82. What is the ratio of the Debt(% of exports of goods, services and primary income) in Pacific island small states in 2010 to that in 2011?
Your response must be concise. 0.31. What is the ratio of the Debt(% of exports of goods, services and primary income) in Bosnia and Herzegovina in 2010 to that in 2011?
Your response must be concise. 0.98. What is the ratio of the Debt(% of exports of goods, services and primary income) in Macedonia in 2010 to that in 2011?
Make the answer very short. 1.09. What is the ratio of the Debt(% of exports of goods, services and primary income) in Pacific island small states in 2010 to that in 2012?
Keep it short and to the point. 1.04. What is the ratio of the Debt(% of exports of goods, services and primary income) in Bosnia and Herzegovina in 2010 to that in 2012?
Your answer should be compact. 0.8. What is the ratio of the Debt(% of exports of goods, services and primary income) in Macedonia in 2010 to that in 2012?
Your answer should be compact. 0.78. What is the ratio of the Debt(% of exports of goods, services and primary income) of Pacific island small states in 2011 to that in 2012?
Offer a terse response. 3.39. What is the ratio of the Debt(% of exports of goods, services and primary income) of Bosnia and Herzegovina in 2011 to that in 2012?
Offer a terse response. 0.81. What is the ratio of the Debt(% of exports of goods, services and primary income) of Macedonia in 2011 to that in 2012?
Your response must be concise. 0.72. What is the difference between the highest and the second highest Debt(% of exports of goods, services and primary income) of Pacific island small states?
Your response must be concise. 3.87. What is the difference between the highest and the second highest Debt(% of exports of goods, services and primary income) in Bosnia and Herzegovina?
Ensure brevity in your answer.  0.89. What is the difference between the highest and the second highest Debt(% of exports of goods, services and primary income) of Macedonia?
Keep it short and to the point. 3.31. What is the difference between the highest and the lowest Debt(% of exports of goods, services and primary income) in Pacific island small states?
Your response must be concise. 4.57. What is the difference between the highest and the lowest Debt(% of exports of goods, services and primary income) in Bosnia and Herzegovina?
Give a very brief answer. 1.93. What is the difference between the highest and the lowest Debt(% of exports of goods, services and primary income) in Macedonia?
Make the answer very short. 10.93. 